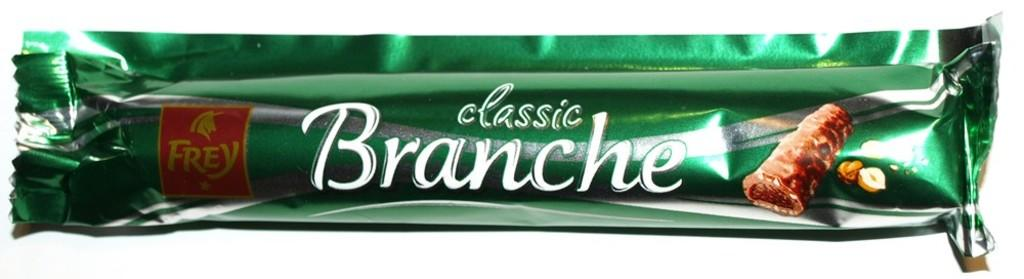<image>
Offer a succinct explanation of the picture presented. A classic Branche candy bar is made with chocolate. 